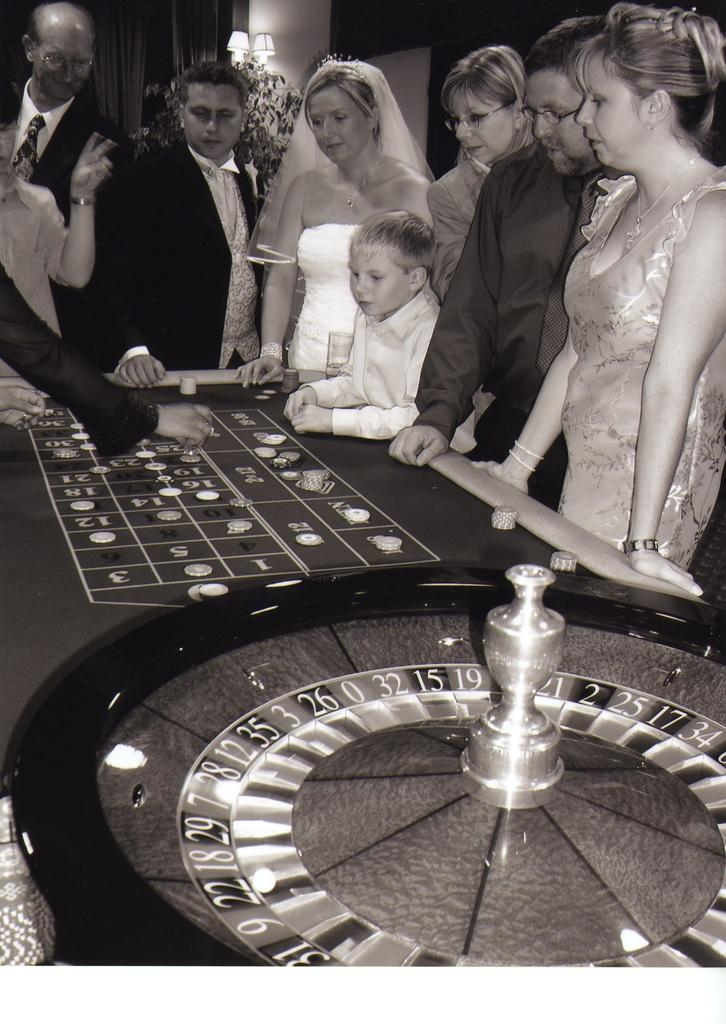What are the people in the image doing? The persons are standing in front of a table. What is on the table in the image? There are coins, a wheel, and numbers on the table. What can be seen in the background of the image? There are lantern lamps and curtains in the background. How is the image presented? The image is black and white. Can you tell me how many horses are present in the image? There are no horses present in the image. What type of toy can be seen on the table? There is no toy present on the table; it contains coins, a wheel, and numbers. 